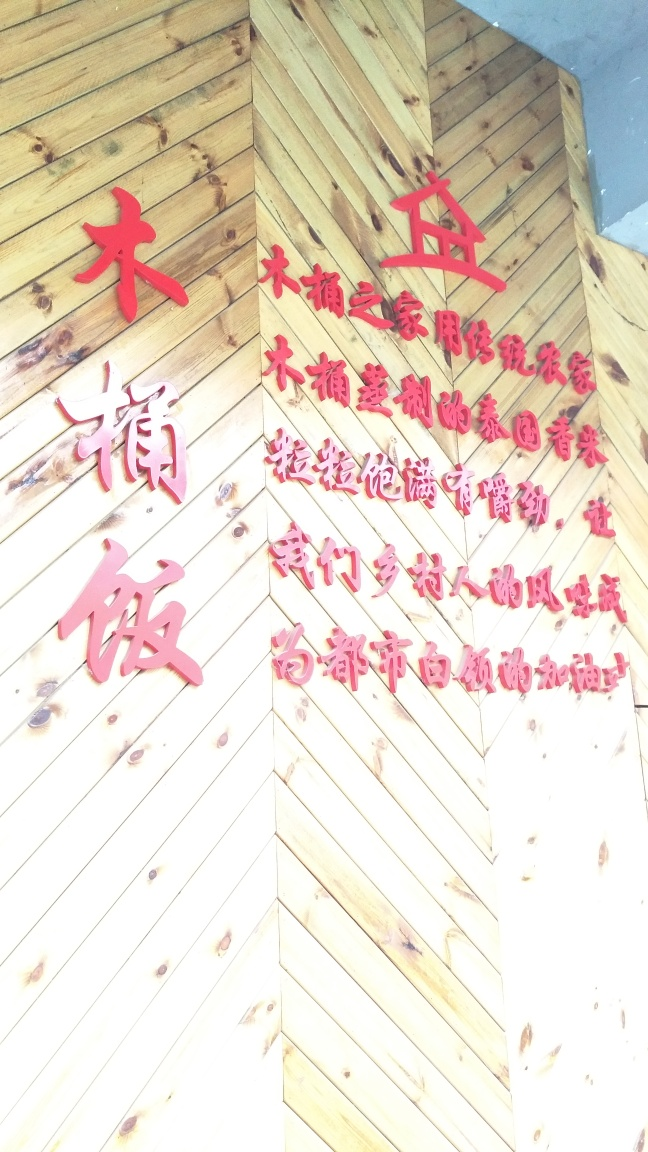Can you describe what's in this image? The image shows a wooden structure with red Chinese characters on it. The characters are decorative and bold, likely signifying an important message or place. However, there's overexposure in the photograph which somewhat obscures the finer details. Could these characters be from a specific event or establishment? It's possible. The characters look stylistic and are often found at locations such as restaurants, temples, or traditional businesses, where they can serve as an aesthetic feature, a welcome sign, or convey cultural significance. 